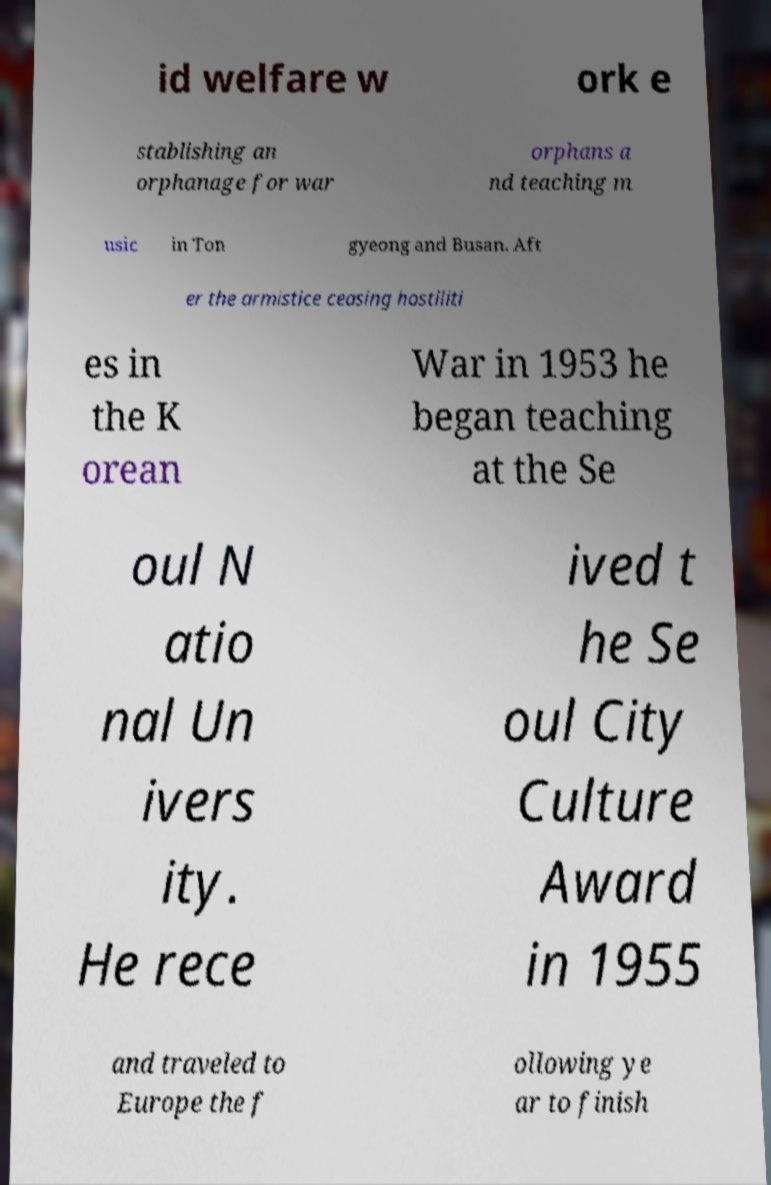There's text embedded in this image that I need extracted. Can you transcribe it verbatim? id welfare w ork e stablishing an orphanage for war orphans a nd teaching m usic in Ton gyeong and Busan. Aft er the armistice ceasing hostiliti es in the K orean War in 1953 he began teaching at the Se oul N atio nal Un ivers ity. He rece ived t he Se oul City Culture Award in 1955 and traveled to Europe the f ollowing ye ar to finish 